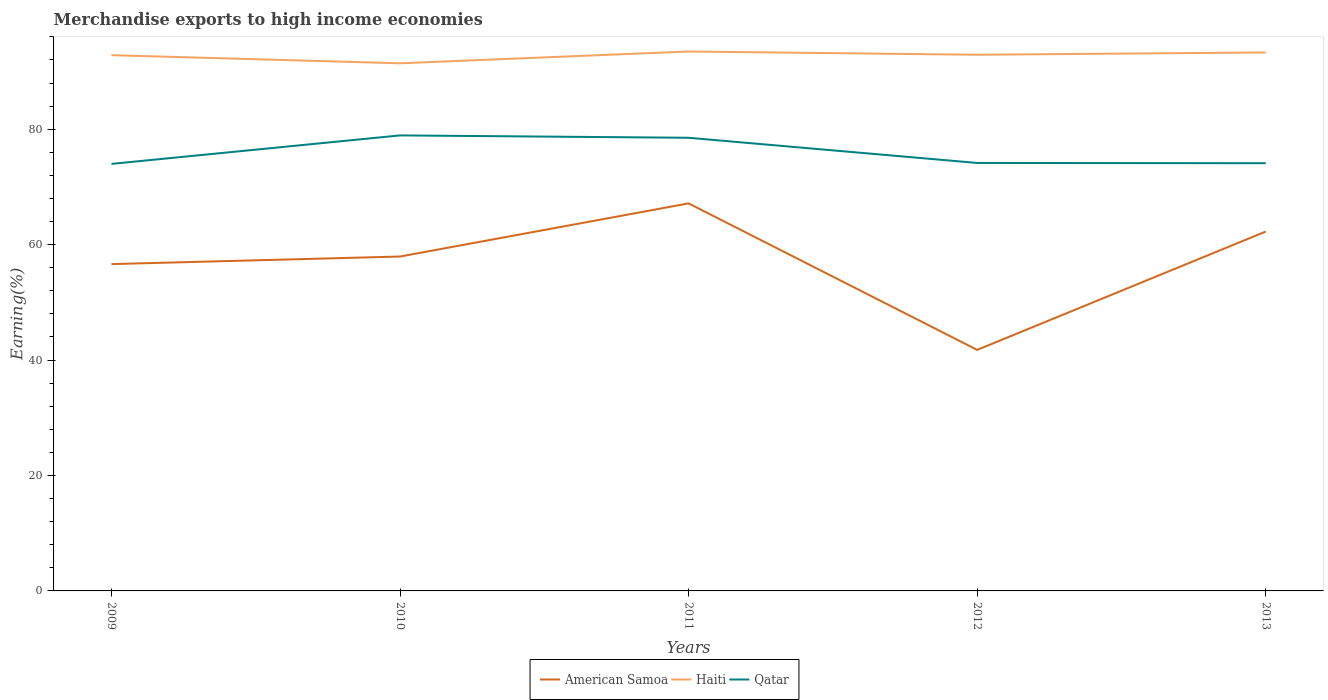Across all years, what is the maximum percentage of amount earned from merchandise exports in Qatar?
Make the answer very short. 73.98. What is the total percentage of amount earned from merchandise exports in American Samoa in the graph?
Give a very brief answer. 14.86. What is the difference between the highest and the second highest percentage of amount earned from merchandise exports in American Samoa?
Provide a short and direct response. 25.38. What is the difference between the highest and the lowest percentage of amount earned from merchandise exports in Qatar?
Keep it short and to the point. 2. Is the percentage of amount earned from merchandise exports in American Samoa strictly greater than the percentage of amount earned from merchandise exports in Haiti over the years?
Give a very brief answer. Yes. How many lines are there?
Offer a terse response. 3. How many years are there in the graph?
Provide a succinct answer. 5. Does the graph contain grids?
Give a very brief answer. No. How are the legend labels stacked?
Make the answer very short. Horizontal. What is the title of the graph?
Keep it short and to the point. Merchandise exports to high income economies. Does "Panama" appear as one of the legend labels in the graph?
Your response must be concise. No. What is the label or title of the X-axis?
Your response must be concise. Years. What is the label or title of the Y-axis?
Make the answer very short. Earning(%). What is the Earning(%) of American Samoa in 2009?
Provide a succinct answer. 56.63. What is the Earning(%) of Haiti in 2009?
Make the answer very short. 92.82. What is the Earning(%) in Qatar in 2009?
Keep it short and to the point. 73.98. What is the Earning(%) of American Samoa in 2010?
Provide a succinct answer. 57.94. What is the Earning(%) of Haiti in 2010?
Your answer should be compact. 91.41. What is the Earning(%) of Qatar in 2010?
Provide a short and direct response. 78.92. What is the Earning(%) of American Samoa in 2011?
Offer a terse response. 67.14. What is the Earning(%) of Haiti in 2011?
Offer a very short reply. 93.46. What is the Earning(%) of Qatar in 2011?
Give a very brief answer. 78.51. What is the Earning(%) in American Samoa in 2012?
Give a very brief answer. 41.76. What is the Earning(%) in Haiti in 2012?
Your answer should be compact. 92.9. What is the Earning(%) in Qatar in 2012?
Provide a short and direct response. 74.15. What is the Earning(%) of American Samoa in 2013?
Provide a short and direct response. 62.27. What is the Earning(%) in Haiti in 2013?
Provide a succinct answer. 93.3. What is the Earning(%) in Qatar in 2013?
Keep it short and to the point. 74.11. Across all years, what is the maximum Earning(%) in American Samoa?
Make the answer very short. 67.14. Across all years, what is the maximum Earning(%) in Haiti?
Give a very brief answer. 93.46. Across all years, what is the maximum Earning(%) of Qatar?
Your response must be concise. 78.92. Across all years, what is the minimum Earning(%) in American Samoa?
Make the answer very short. 41.76. Across all years, what is the minimum Earning(%) in Haiti?
Offer a terse response. 91.41. Across all years, what is the minimum Earning(%) of Qatar?
Provide a succinct answer. 73.98. What is the total Earning(%) of American Samoa in the graph?
Make the answer very short. 285.73. What is the total Earning(%) of Haiti in the graph?
Give a very brief answer. 463.89. What is the total Earning(%) of Qatar in the graph?
Give a very brief answer. 379.67. What is the difference between the Earning(%) of American Samoa in 2009 and that in 2010?
Your answer should be compact. -1.31. What is the difference between the Earning(%) of Haiti in 2009 and that in 2010?
Provide a succinct answer. 1.41. What is the difference between the Earning(%) of Qatar in 2009 and that in 2010?
Make the answer very short. -4.94. What is the difference between the Earning(%) in American Samoa in 2009 and that in 2011?
Your answer should be compact. -10.52. What is the difference between the Earning(%) in Haiti in 2009 and that in 2011?
Ensure brevity in your answer.  -0.64. What is the difference between the Earning(%) of Qatar in 2009 and that in 2011?
Make the answer very short. -4.53. What is the difference between the Earning(%) of American Samoa in 2009 and that in 2012?
Keep it short and to the point. 14.86. What is the difference between the Earning(%) in Haiti in 2009 and that in 2012?
Provide a succinct answer. -0.07. What is the difference between the Earning(%) in Qatar in 2009 and that in 2012?
Provide a succinct answer. -0.16. What is the difference between the Earning(%) in American Samoa in 2009 and that in 2013?
Your answer should be compact. -5.64. What is the difference between the Earning(%) of Haiti in 2009 and that in 2013?
Your answer should be very brief. -0.47. What is the difference between the Earning(%) in Qatar in 2009 and that in 2013?
Provide a succinct answer. -0.12. What is the difference between the Earning(%) in American Samoa in 2010 and that in 2011?
Your answer should be very brief. -9.21. What is the difference between the Earning(%) in Haiti in 2010 and that in 2011?
Your answer should be compact. -2.04. What is the difference between the Earning(%) of Qatar in 2010 and that in 2011?
Give a very brief answer. 0.41. What is the difference between the Earning(%) of American Samoa in 2010 and that in 2012?
Give a very brief answer. 16.17. What is the difference between the Earning(%) in Haiti in 2010 and that in 2012?
Keep it short and to the point. -1.48. What is the difference between the Earning(%) in Qatar in 2010 and that in 2012?
Make the answer very short. 4.77. What is the difference between the Earning(%) in American Samoa in 2010 and that in 2013?
Your response must be concise. -4.33. What is the difference between the Earning(%) in Haiti in 2010 and that in 2013?
Provide a succinct answer. -1.88. What is the difference between the Earning(%) of Qatar in 2010 and that in 2013?
Keep it short and to the point. 4.82. What is the difference between the Earning(%) of American Samoa in 2011 and that in 2012?
Keep it short and to the point. 25.38. What is the difference between the Earning(%) in Haiti in 2011 and that in 2012?
Make the answer very short. 0.56. What is the difference between the Earning(%) in Qatar in 2011 and that in 2012?
Your answer should be very brief. 4.36. What is the difference between the Earning(%) in American Samoa in 2011 and that in 2013?
Give a very brief answer. 4.88. What is the difference between the Earning(%) of Haiti in 2011 and that in 2013?
Your response must be concise. 0.16. What is the difference between the Earning(%) in Qatar in 2011 and that in 2013?
Keep it short and to the point. 4.41. What is the difference between the Earning(%) of American Samoa in 2012 and that in 2013?
Your answer should be compact. -20.5. What is the difference between the Earning(%) in Haiti in 2012 and that in 2013?
Offer a very short reply. -0.4. What is the difference between the Earning(%) in Qatar in 2012 and that in 2013?
Make the answer very short. 0.04. What is the difference between the Earning(%) in American Samoa in 2009 and the Earning(%) in Haiti in 2010?
Make the answer very short. -34.79. What is the difference between the Earning(%) in American Samoa in 2009 and the Earning(%) in Qatar in 2010?
Provide a short and direct response. -22.3. What is the difference between the Earning(%) in Haiti in 2009 and the Earning(%) in Qatar in 2010?
Your answer should be compact. 13.9. What is the difference between the Earning(%) of American Samoa in 2009 and the Earning(%) of Haiti in 2011?
Keep it short and to the point. -36.83. What is the difference between the Earning(%) in American Samoa in 2009 and the Earning(%) in Qatar in 2011?
Give a very brief answer. -21.89. What is the difference between the Earning(%) of Haiti in 2009 and the Earning(%) of Qatar in 2011?
Keep it short and to the point. 14.31. What is the difference between the Earning(%) in American Samoa in 2009 and the Earning(%) in Haiti in 2012?
Make the answer very short. -36.27. What is the difference between the Earning(%) in American Samoa in 2009 and the Earning(%) in Qatar in 2012?
Your answer should be compact. -17.52. What is the difference between the Earning(%) in Haiti in 2009 and the Earning(%) in Qatar in 2012?
Give a very brief answer. 18.67. What is the difference between the Earning(%) of American Samoa in 2009 and the Earning(%) of Haiti in 2013?
Your answer should be very brief. -36.67. What is the difference between the Earning(%) in American Samoa in 2009 and the Earning(%) in Qatar in 2013?
Provide a succinct answer. -17.48. What is the difference between the Earning(%) in Haiti in 2009 and the Earning(%) in Qatar in 2013?
Your answer should be compact. 18.72. What is the difference between the Earning(%) in American Samoa in 2010 and the Earning(%) in Haiti in 2011?
Keep it short and to the point. -35.52. What is the difference between the Earning(%) of American Samoa in 2010 and the Earning(%) of Qatar in 2011?
Your answer should be very brief. -20.58. What is the difference between the Earning(%) in Haiti in 2010 and the Earning(%) in Qatar in 2011?
Make the answer very short. 12.9. What is the difference between the Earning(%) in American Samoa in 2010 and the Earning(%) in Haiti in 2012?
Your answer should be compact. -34.96. What is the difference between the Earning(%) of American Samoa in 2010 and the Earning(%) of Qatar in 2012?
Your response must be concise. -16.21. What is the difference between the Earning(%) in Haiti in 2010 and the Earning(%) in Qatar in 2012?
Your answer should be compact. 17.27. What is the difference between the Earning(%) in American Samoa in 2010 and the Earning(%) in Haiti in 2013?
Your response must be concise. -35.36. What is the difference between the Earning(%) in American Samoa in 2010 and the Earning(%) in Qatar in 2013?
Keep it short and to the point. -16.17. What is the difference between the Earning(%) in Haiti in 2010 and the Earning(%) in Qatar in 2013?
Provide a succinct answer. 17.31. What is the difference between the Earning(%) of American Samoa in 2011 and the Earning(%) of Haiti in 2012?
Ensure brevity in your answer.  -25.75. What is the difference between the Earning(%) in American Samoa in 2011 and the Earning(%) in Qatar in 2012?
Provide a succinct answer. -7.01. What is the difference between the Earning(%) of Haiti in 2011 and the Earning(%) of Qatar in 2012?
Provide a short and direct response. 19.31. What is the difference between the Earning(%) in American Samoa in 2011 and the Earning(%) in Haiti in 2013?
Keep it short and to the point. -26.15. What is the difference between the Earning(%) in American Samoa in 2011 and the Earning(%) in Qatar in 2013?
Offer a terse response. -6.96. What is the difference between the Earning(%) in Haiti in 2011 and the Earning(%) in Qatar in 2013?
Offer a terse response. 19.35. What is the difference between the Earning(%) of American Samoa in 2012 and the Earning(%) of Haiti in 2013?
Ensure brevity in your answer.  -51.53. What is the difference between the Earning(%) of American Samoa in 2012 and the Earning(%) of Qatar in 2013?
Provide a succinct answer. -32.34. What is the difference between the Earning(%) of Haiti in 2012 and the Earning(%) of Qatar in 2013?
Offer a terse response. 18.79. What is the average Earning(%) in American Samoa per year?
Your answer should be compact. 57.15. What is the average Earning(%) of Haiti per year?
Offer a terse response. 92.78. What is the average Earning(%) in Qatar per year?
Your answer should be very brief. 75.93. In the year 2009, what is the difference between the Earning(%) of American Samoa and Earning(%) of Haiti?
Your response must be concise. -36.2. In the year 2009, what is the difference between the Earning(%) in American Samoa and Earning(%) in Qatar?
Provide a succinct answer. -17.36. In the year 2009, what is the difference between the Earning(%) in Haiti and Earning(%) in Qatar?
Offer a very short reply. 18.84. In the year 2010, what is the difference between the Earning(%) of American Samoa and Earning(%) of Haiti?
Provide a succinct answer. -33.48. In the year 2010, what is the difference between the Earning(%) of American Samoa and Earning(%) of Qatar?
Keep it short and to the point. -20.99. In the year 2010, what is the difference between the Earning(%) of Haiti and Earning(%) of Qatar?
Make the answer very short. 12.49. In the year 2011, what is the difference between the Earning(%) in American Samoa and Earning(%) in Haiti?
Your response must be concise. -26.32. In the year 2011, what is the difference between the Earning(%) of American Samoa and Earning(%) of Qatar?
Your response must be concise. -11.37. In the year 2011, what is the difference between the Earning(%) of Haiti and Earning(%) of Qatar?
Provide a short and direct response. 14.95. In the year 2012, what is the difference between the Earning(%) in American Samoa and Earning(%) in Haiti?
Keep it short and to the point. -51.13. In the year 2012, what is the difference between the Earning(%) in American Samoa and Earning(%) in Qatar?
Make the answer very short. -32.39. In the year 2012, what is the difference between the Earning(%) of Haiti and Earning(%) of Qatar?
Ensure brevity in your answer.  18.75. In the year 2013, what is the difference between the Earning(%) in American Samoa and Earning(%) in Haiti?
Keep it short and to the point. -31.03. In the year 2013, what is the difference between the Earning(%) in American Samoa and Earning(%) in Qatar?
Your response must be concise. -11.84. In the year 2013, what is the difference between the Earning(%) in Haiti and Earning(%) in Qatar?
Make the answer very short. 19.19. What is the ratio of the Earning(%) in American Samoa in 2009 to that in 2010?
Provide a succinct answer. 0.98. What is the ratio of the Earning(%) of Haiti in 2009 to that in 2010?
Your response must be concise. 1.02. What is the ratio of the Earning(%) in Qatar in 2009 to that in 2010?
Keep it short and to the point. 0.94. What is the ratio of the Earning(%) of American Samoa in 2009 to that in 2011?
Ensure brevity in your answer.  0.84. What is the ratio of the Earning(%) of Qatar in 2009 to that in 2011?
Provide a succinct answer. 0.94. What is the ratio of the Earning(%) in American Samoa in 2009 to that in 2012?
Your answer should be compact. 1.36. What is the ratio of the Earning(%) of Haiti in 2009 to that in 2012?
Make the answer very short. 1. What is the ratio of the Earning(%) of American Samoa in 2009 to that in 2013?
Provide a short and direct response. 0.91. What is the ratio of the Earning(%) in Haiti in 2009 to that in 2013?
Give a very brief answer. 0.99. What is the ratio of the Earning(%) in Qatar in 2009 to that in 2013?
Offer a terse response. 1. What is the ratio of the Earning(%) in American Samoa in 2010 to that in 2011?
Ensure brevity in your answer.  0.86. What is the ratio of the Earning(%) of Haiti in 2010 to that in 2011?
Your response must be concise. 0.98. What is the ratio of the Earning(%) of American Samoa in 2010 to that in 2012?
Ensure brevity in your answer.  1.39. What is the ratio of the Earning(%) in Haiti in 2010 to that in 2012?
Your response must be concise. 0.98. What is the ratio of the Earning(%) in Qatar in 2010 to that in 2012?
Offer a very short reply. 1.06. What is the ratio of the Earning(%) in American Samoa in 2010 to that in 2013?
Make the answer very short. 0.93. What is the ratio of the Earning(%) in Haiti in 2010 to that in 2013?
Your answer should be very brief. 0.98. What is the ratio of the Earning(%) of Qatar in 2010 to that in 2013?
Provide a succinct answer. 1.06. What is the ratio of the Earning(%) in American Samoa in 2011 to that in 2012?
Give a very brief answer. 1.61. What is the ratio of the Earning(%) of Qatar in 2011 to that in 2012?
Offer a very short reply. 1.06. What is the ratio of the Earning(%) in American Samoa in 2011 to that in 2013?
Your answer should be very brief. 1.08. What is the ratio of the Earning(%) of Qatar in 2011 to that in 2013?
Your answer should be very brief. 1.06. What is the ratio of the Earning(%) in American Samoa in 2012 to that in 2013?
Your answer should be compact. 0.67. What is the ratio of the Earning(%) in Haiti in 2012 to that in 2013?
Your answer should be compact. 1. What is the difference between the highest and the second highest Earning(%) of American Samoa?
Provide a short and direct response. 4.88. What is the difference between the highest and the second highest Earning(%) of Haiti?
Your answer should be very brief. 0.16. What is the difference between the highest and the second highest Earning(%) of Qatar?
Your response must be concise. 0.41. What is the difference between the highest and the lowest Earning(%) of American Samoa?
Keep it short and to the point. 25.38. What is the difference between the highest and the lowest Earning(%) of Haiti?
Your answer should be compact. 2.04. What is the difference between the highest and the lowest Earning(%) in Qatar?
Give a very brief answer. 4.94. 